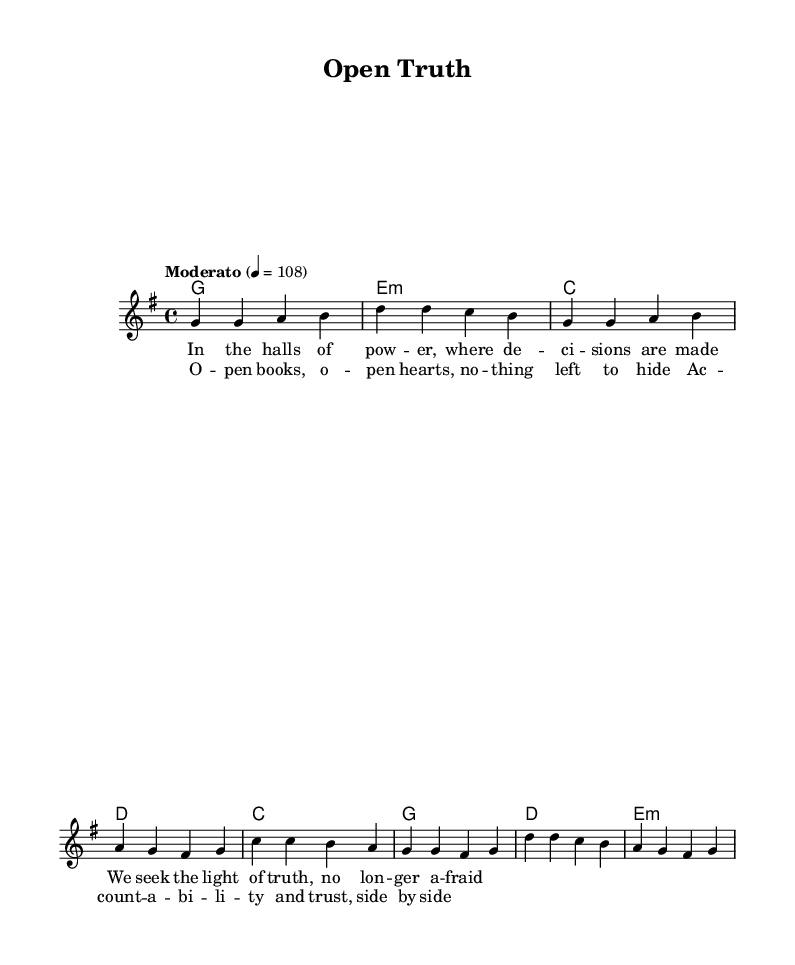What is the key signature of this music? The key signature shows one sharp, indicating that the music is in G major since G major has one sharp (F#).
Answer: G major What is the time signature of this music? The time signature is indicated at the beginning of the score, where it states 4/4, meaning there are four beats in each measure and a quarter note gets one beat.
Answer: 4/4 What is the tempo marking for this music? The tempo marking says "Moderato," which suggests a moderate speed of around 108 beats per minute, and is written explicitly in the score.
Answer: Moderato How many measures are in the verse section? The verse section consists of 4 measures, as counted through the melody section where each group of notes corresponds to a measure.
Answer: 4 What is the musical structure of the song? The structure alternates between a verse and a chorus, as indicated by the organization of the melody and lyrics. The verse comes first, followed by the chorus.
Answer: Verse-Chorus What are the lyrics of the chorus? The lyrics of the chorus are explicitly provided in the score and describe themes of accountability and transparency, directly corresponding to the musical notes in the chorus section.
Answer: Open books, open hearts, nothing left to hide Which chord is used in the second measure of the verse? The second measure of the verse shows an E minor chord written in the harmonies section, represented by the symbol "e:m" under the chord names.
Answer: E minor 